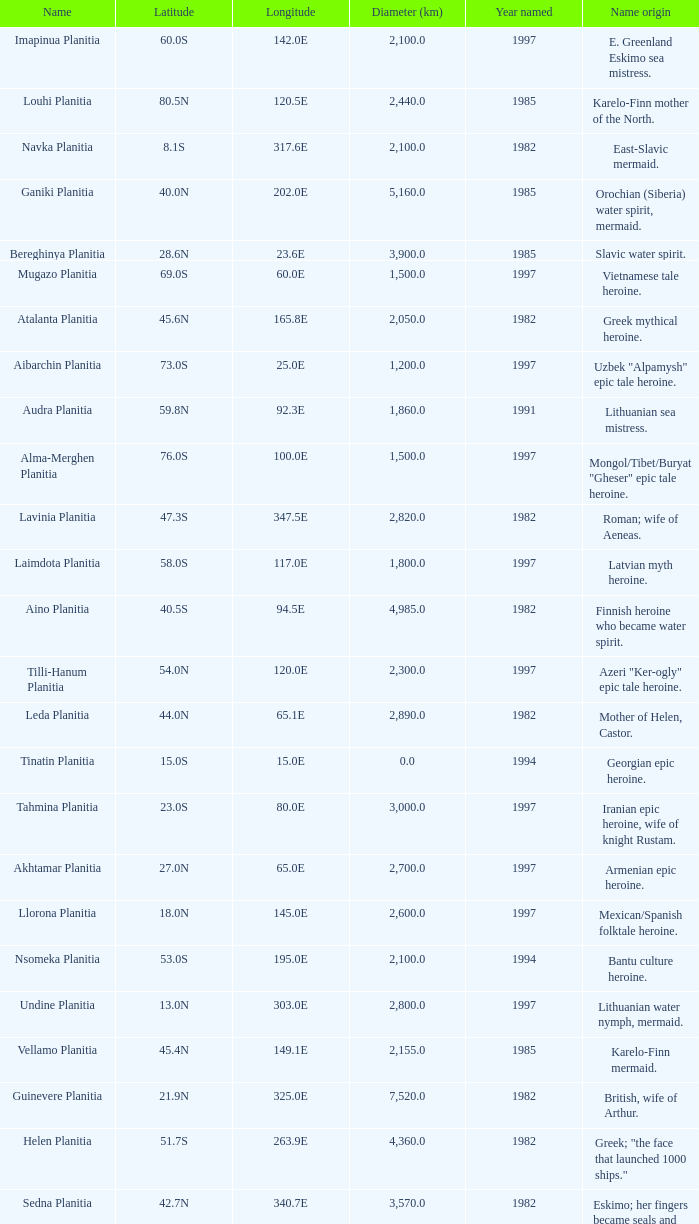What is the diameter (km) of the feature of latitude 23.0s 3000.0. 